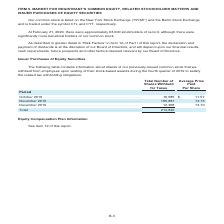According to Centurylink's financial document, What information does the table contain? information about shares of our previously-issued common stock that we withheld from employees upon vesting of their stock-based awards during the fourth quarter of 2019 to satisfy the related tax withholding obligations. The document states: "The following table contains information about shares of our previously-issued common stock that we withheld from employees upon vesting of their stoc..." Also, What is the average price paid per share in October 2019? According to the financial document, $11.57. The relevant text states: "Period October 2019 . 16,585 $ 11.57 November 2019 . 185,887 13.15 December 2019 . 12,368 13.70..." Also, Which periods does the table contain? The document contains multiple relevant values: October 2019, November 2019, December 2019. From the document: "19 . 16,585 $ 11.57 November 2019 . 185,887 13.15 December 2019 . 12,368 13.70 Period October 2019 . 16,585 $ 11.57 November 2019 . 185,887 13.15 Dece..." Additionally, Which period has the largest average price paid per share? According to the financial document, December 2019. The relevant text states: "19 . 16,585 $ 11.57 November 2019 . 185,887 13.15 December 2019 . 12,368 13.70..." Also, can you calculate: What is the average number of shares withheld for taxes per month? Based on the calculation: 214,840/3, the result is 71613.33. This is based on the information: "Total . 214,840 .57 November 2019 . 185,887 13.15 December 2019 . 12,368 13.70..." The key data points involved are: 214,840. Also, can you calculate: What is the percentage change in the average price paid per share between December 2019 and November 2019? To answer this question, I need to perform calculations using the financial data. The calculation is: (13.70-13.15)/13.15, which equals 4.18 (percentage). This is based on the information: "ber 2019 . 16,585 $ 11.57 November 2019 . 185,887 13.15 December 2019 . 12,368 13.70 ember 2019 . 185,887 13.15 December 2019 . 12,368 13.70..." The key data points involved are: 13.15, 13.70. 